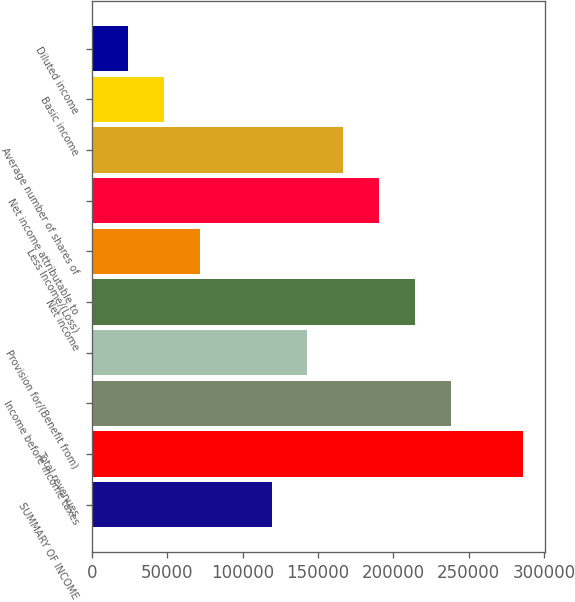Convert chart to OTSL. <chart><loc_0><loc_0><loc_500><loc_500><bar_chart><fcel>SUMMARY OF INCOME<fcel>Total revenues<fcel>Income before income taxes<fcel>Provision for/(Benefit from)<fcel>Net income<fcel>Less Income/(Loss)<fcel>Net income attributable to<fcel>Average number of shares of<fcel>Basic income<fcel>Diluted income<nl><fcel>119255<fcel>286212<fcel>238510<fcel>143106<fcel>214659<fcel>71553.6<fcel>190808<fcel>166957<fcel>47702.7<fcel>23851.8<nl></chart> 